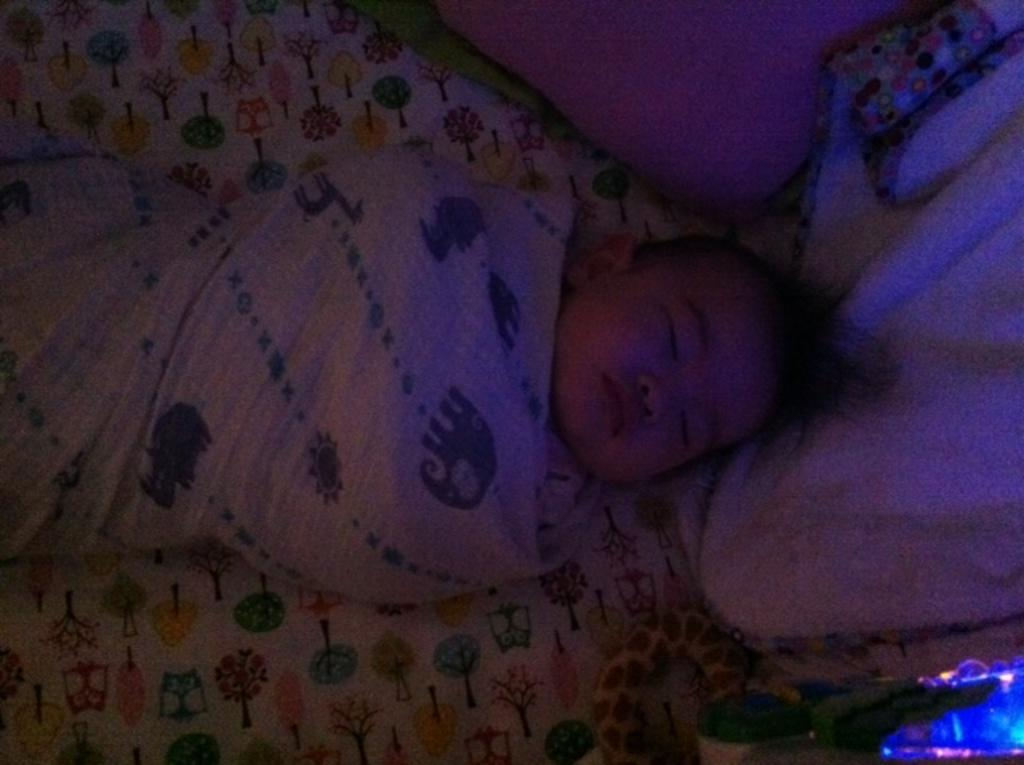What is the main subject of the image? There is a baby in the image. What is the baby doing in the image? The baby is sleeping. How is the baby dressed or covered in the image? The baby is wrapped in a cloth. What other objects can be seen in the image? There is a toy and a pillow in the image. What type of nail is being used to hold the toy in the image? There is no nail present in the image, and the toy is not being held by any object. 